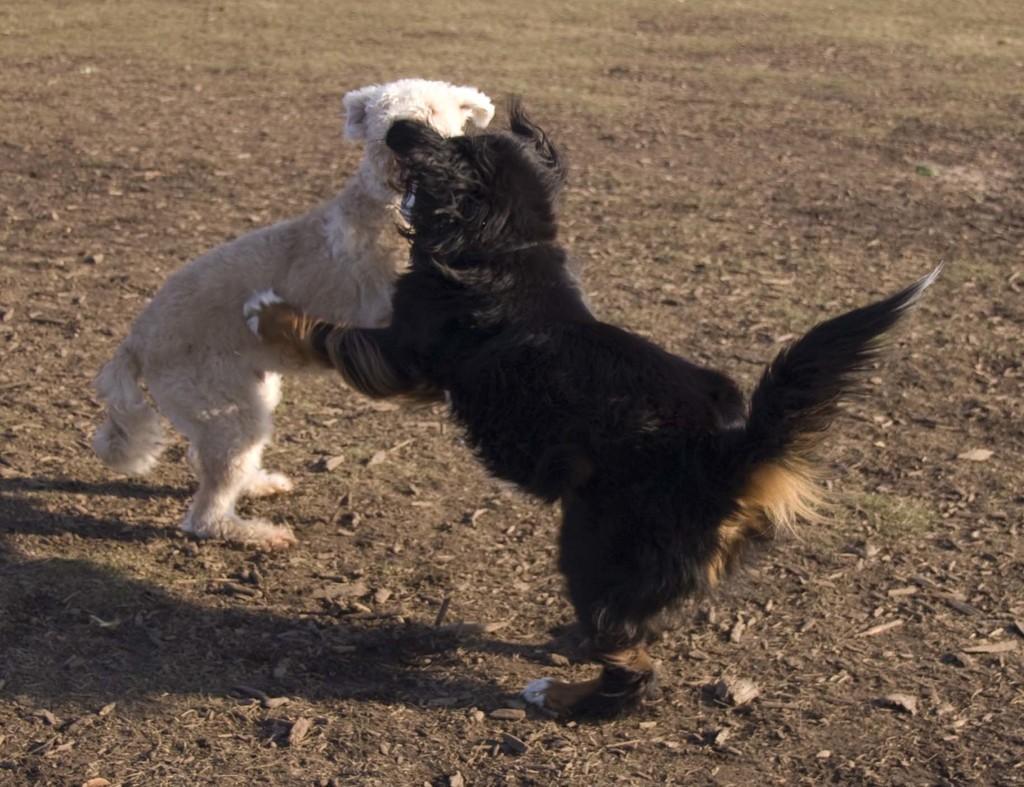Can you describe this image briefly? In this image I can see an open ground and on it I can see two dogs. I can see the colour of one dog is white and the colour of one is black. 